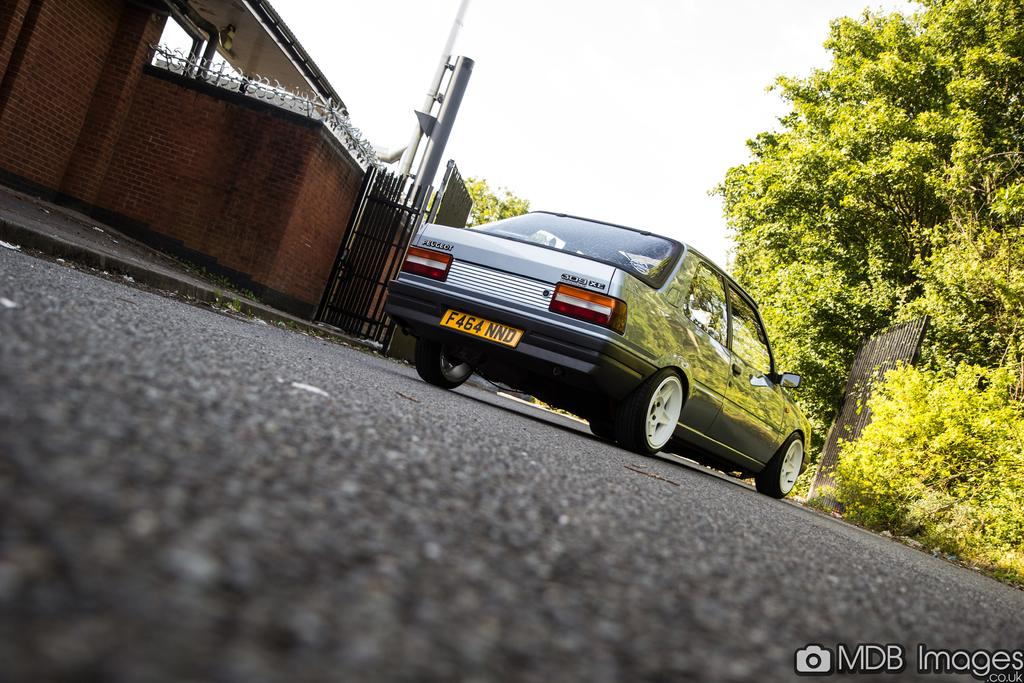What is the main subject of the image? The main subject of the image is a car. Where is the car located in the image? The car is on the road in the image. What can be seen on the left side of the image? There is a brick wall fencing on the left side of the image. What type of vegetation is on the right side of the image? There are trees on the right side of the image. How are the trees positioned in relation to the car? The trees are in front of the car in the image. What type of bells can be heard ringing in the image? There are no bells present in the image, and therefore no sound can be heard. What activity is the man performing in the image? There is no man present in the image, so no activity can be observed. 